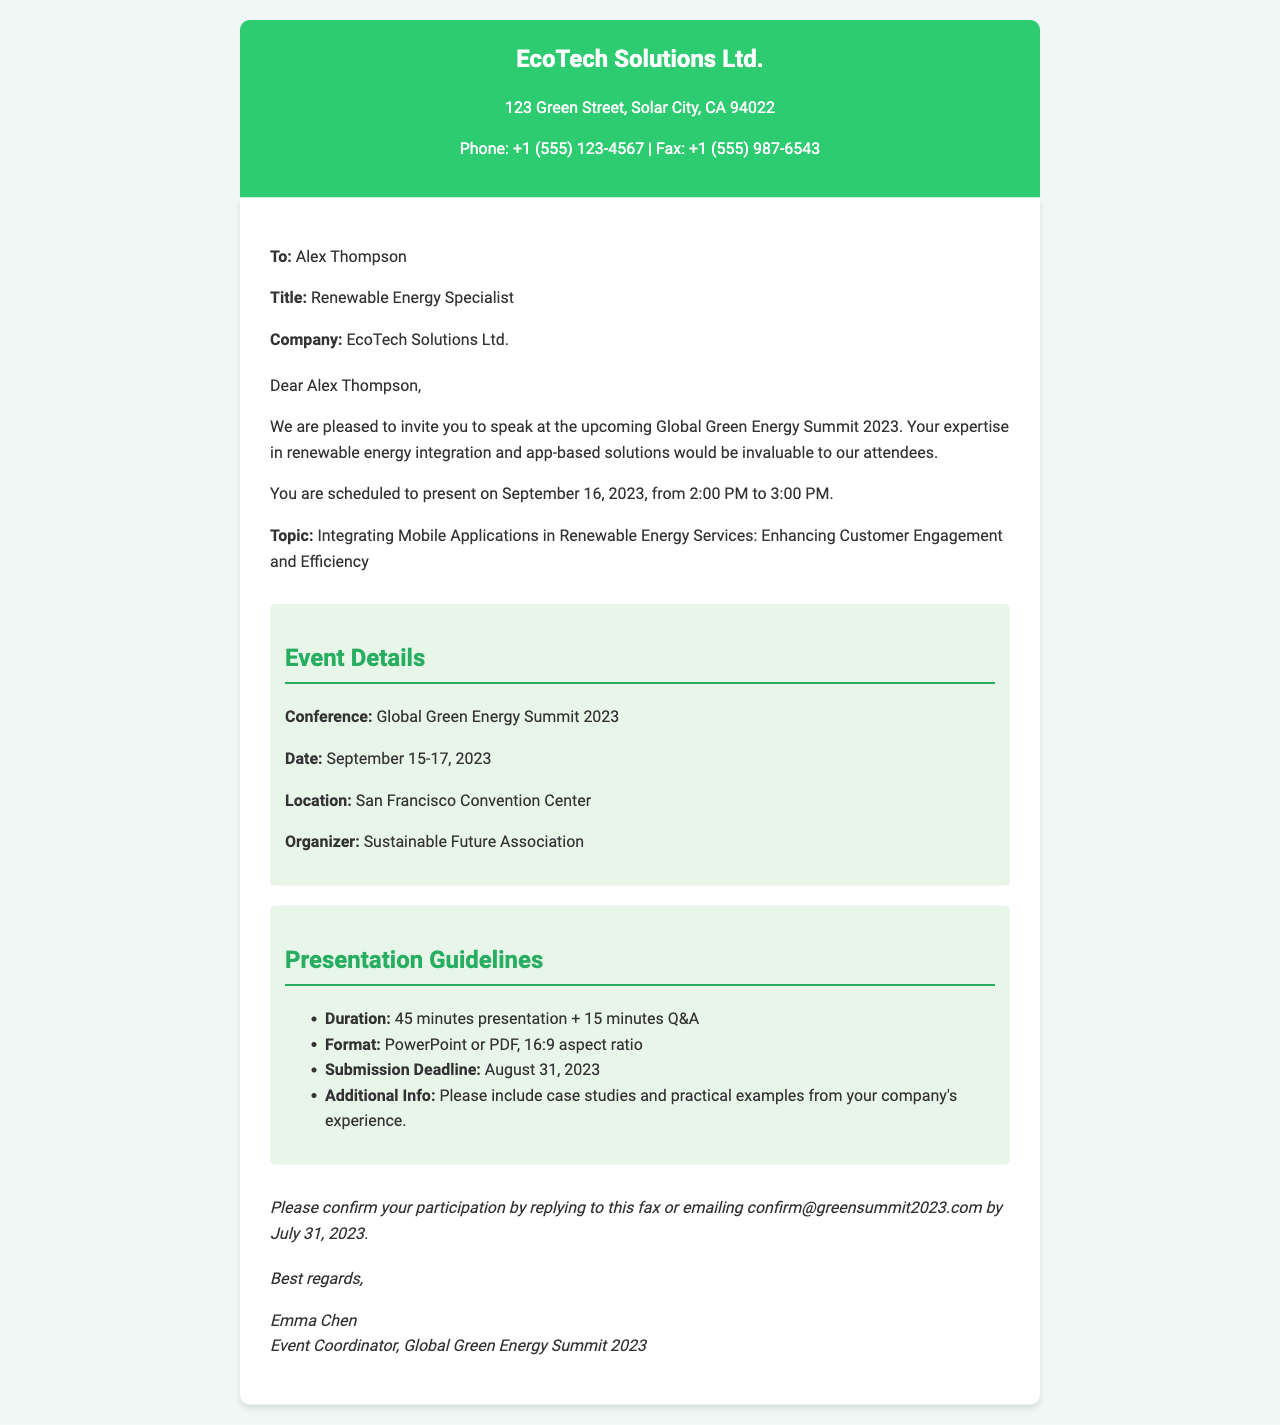What is the name of the conference? The name of the conference is mentioned in the event details section of the document.
Answer: Global Green Energy Summit 2023 What is the date of the presentation? The date of the presentation is specified in the invitation content paragraph.
Answer: September 16, 2023 Who is the event coordinator? The name of the event coordinator is found in the closing section of the document.
Answer: Emma Chen What is the duration of the presentation? The duration of the presentation is outlined in the presentation guidelines section.
Answer: 45 minutes presentation + 15 minutes Q&A What is the submission deadline for the presentation material? The submission deadline is stated in the presentation guidelines section of the document.
Answer: August 31, 2023 What is the topic of the presentation? The topic of the presentation is highlighted in the invitation content paragraph.
Answer: Integrating Mobile Applications in Renewable Energy Services: Enhancing Customer Engagement and Efficiency Where is the conference being held? The location of the conference is provided in the event details section.
Answer: San Francisco Convention Center How can the recipient confirm their participation? The method for confirmation is detailed in the closing paragraph of the document.
Answer: Replying to this fax or emailing confirm@greensummit2023.com What is the aspect ratio for the presentation format? The aspect ratio requirement is specified in the presentation guidelines section.
Answer: 16:9 aspect ratio 